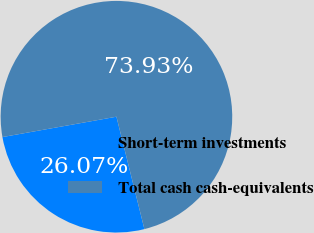Convert chart. <chart><loc_0><loc_0><loc_500><loc_500><pie_chart><fcel>Short-term investments<fcel>Total cash cash-equivalents<nl><fcel>26.07%<fcel>73.93%<nl></chart> 